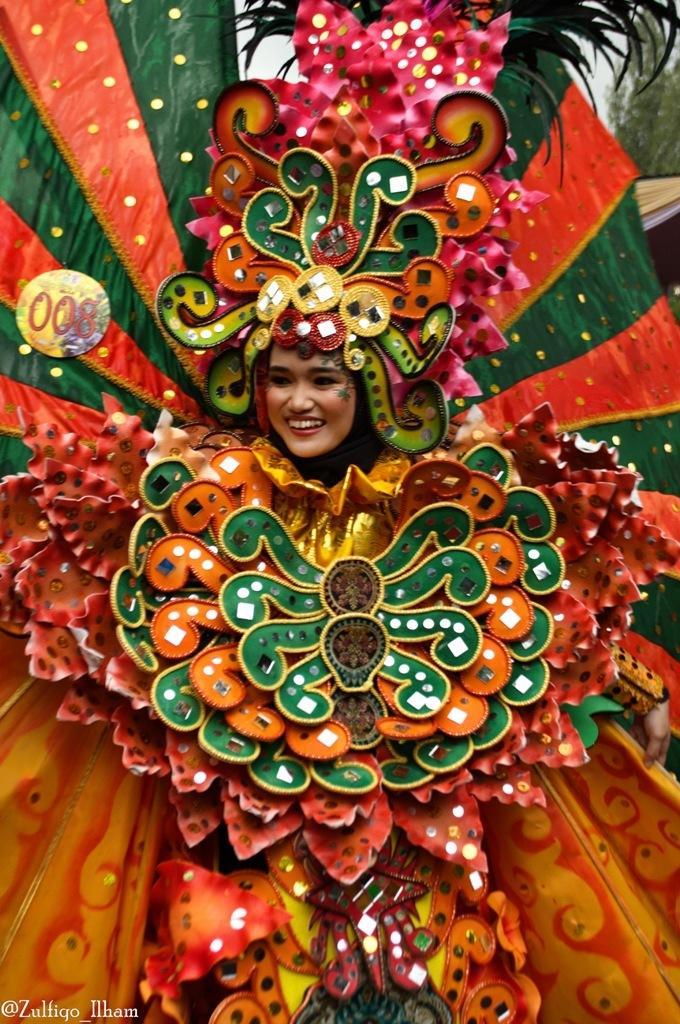Could you give a brief overview of what you see in this image? In the center of the image we can see a lady wearing a costume and she is smiling. 